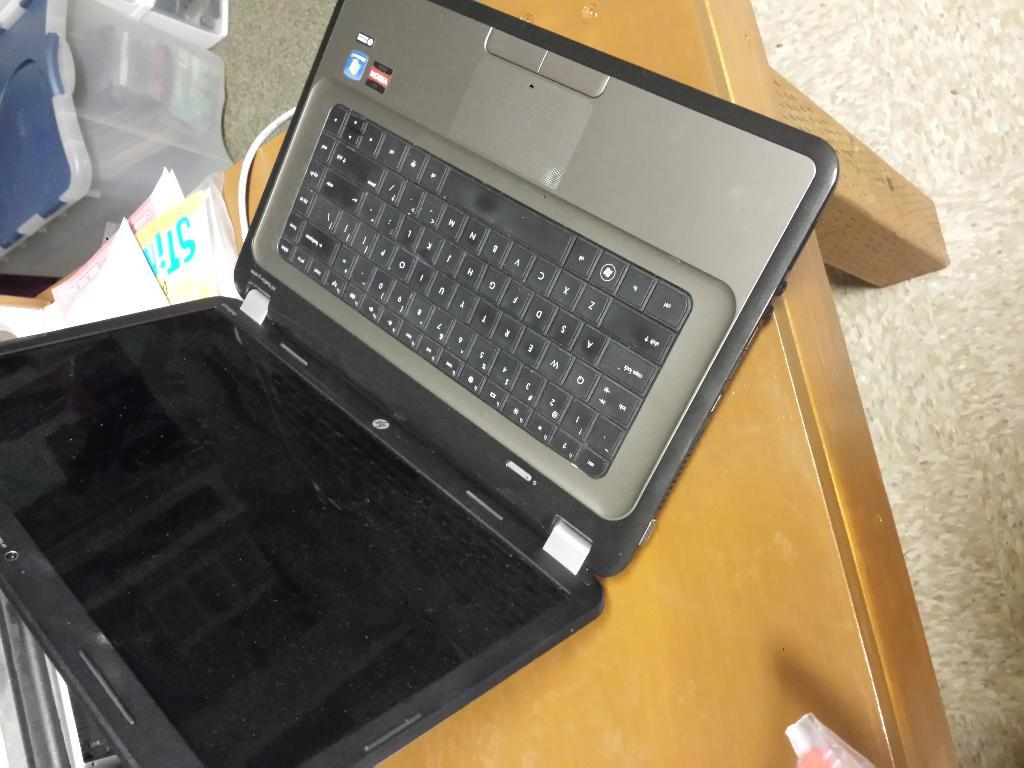Provide a one-sentence caption for the provided image. an HP computer lap top is on a coffee table. 